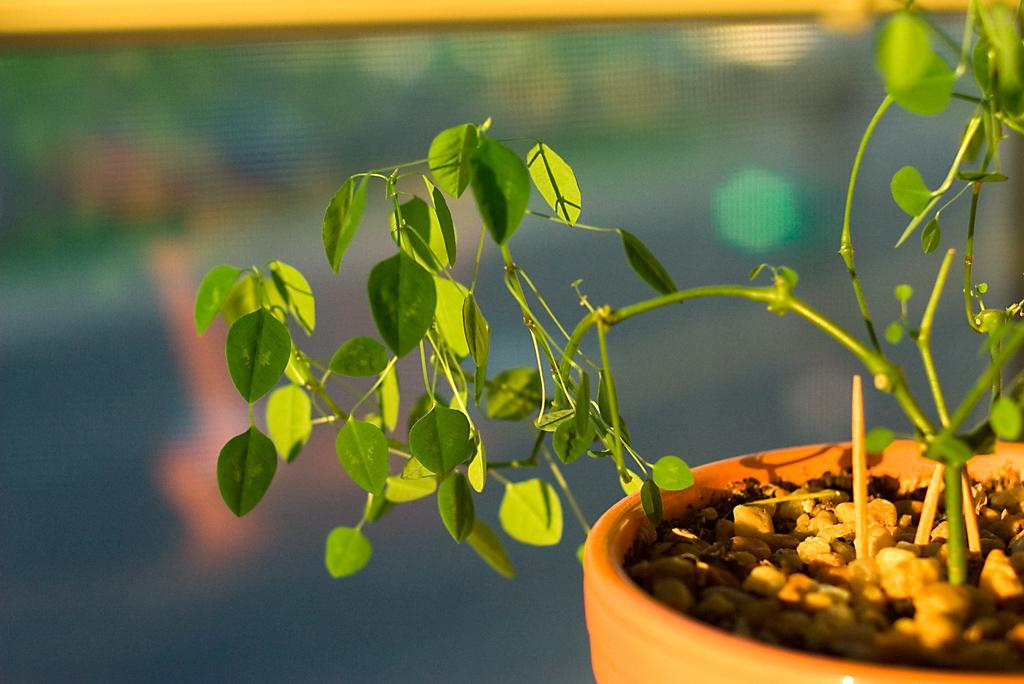What type of living organism is in the image? There is a plant in the image. What color is the plant? The plant is green. What is the plant placed in? The plant is placed in a pot. What color is the pot? The pot is brown. How would you describe the background of the image? The background of the image is blurred. What type of song is being played by the plant in the image? There is no song being played by the plant in the image; it is a static image of a plant in a pot. 